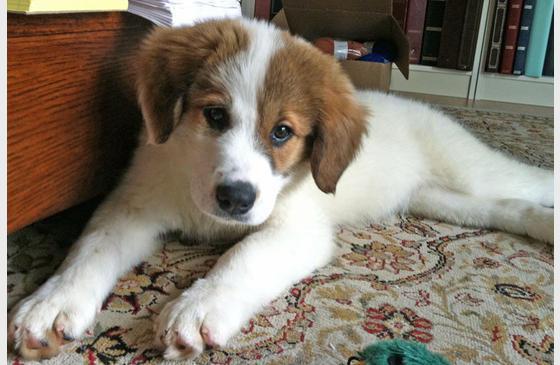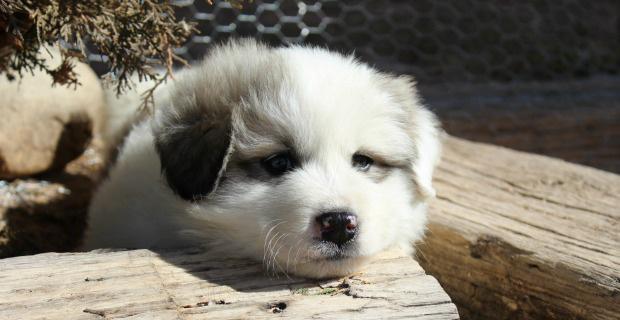The first image is the image on the left, the second image is the image on the right. Evaluate the accuracy of this statement regarding the images: "Each image shows one young puppy, and at least one image shows a brown-eared puppy reclining with its front paws forward.". Is it true? Answer yes or no. Yes. The first image is the image on the left, the second image is the image on the right. Assess this claim about the two images: "One of the images features an adult dog on green grass.". Correct or not? Answer yes or no. No. 